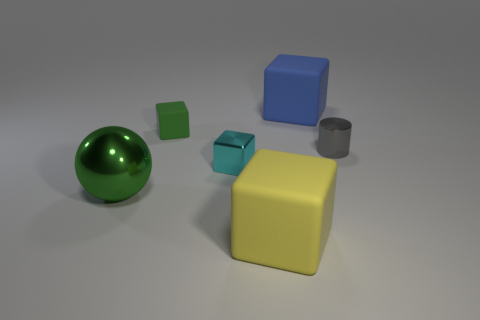What color is the tiny object that is both in front of the small green matte object and to the left of the gray metal object?
Make the answer very short. Cyan. Is there anything else that is the same color as the ball?
Your answer should be very brief. Yes. The small thing that is right of the big rubber thing in front of the small thing to the right of the blue thing is what shape?
Keep it short and to the point. Cylinder. There is a small shiny object that is the same shape as the yellow rubber thing; what color is it?
Your response must be concise. Cyan. What is the color of the rubber object that is to the right of the rubber cube that is in front of the green shiny object?
Your answer should be very brief. Blue. There is a yellow matte object that is the same shape as the blue rubber thing; what is its size?
Your answer should be compact. Large. What number of small cylinders are made of the same material as the large green thing?
Offer a very short reply. 1. How many large green spheres are behind the tiny metal thing on the right side of the cyan block?
Your response must be concise. 0. Are there any big rubber blocks in front of the small cylinder?
Your answer should be compact. Yes. Do the large thing that is behind the tiny rubber cube and the tiny green rubber object have the same shape?
Provide a succinct answer. Yes. 